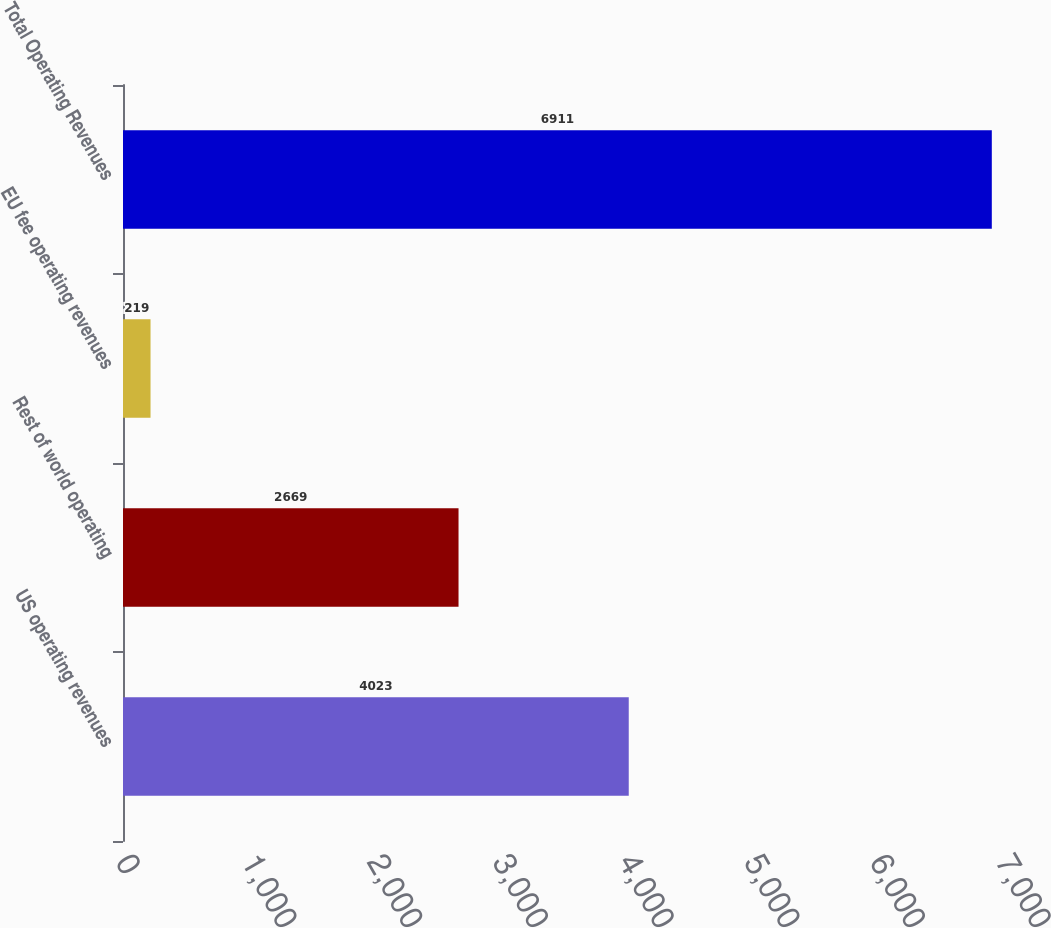Convert chart to OTSL. <chart><loc_0><loc_0><loc_500><loc_500><bar_chart><fcel>US operating revenues<fcel>Rest of world operating<fcel>EU fee operating revenues<fcel>Total Operating Revenues<nl><fcel>4023<fcel>2669<fcel>219<fcel>6911<nl></chart> 